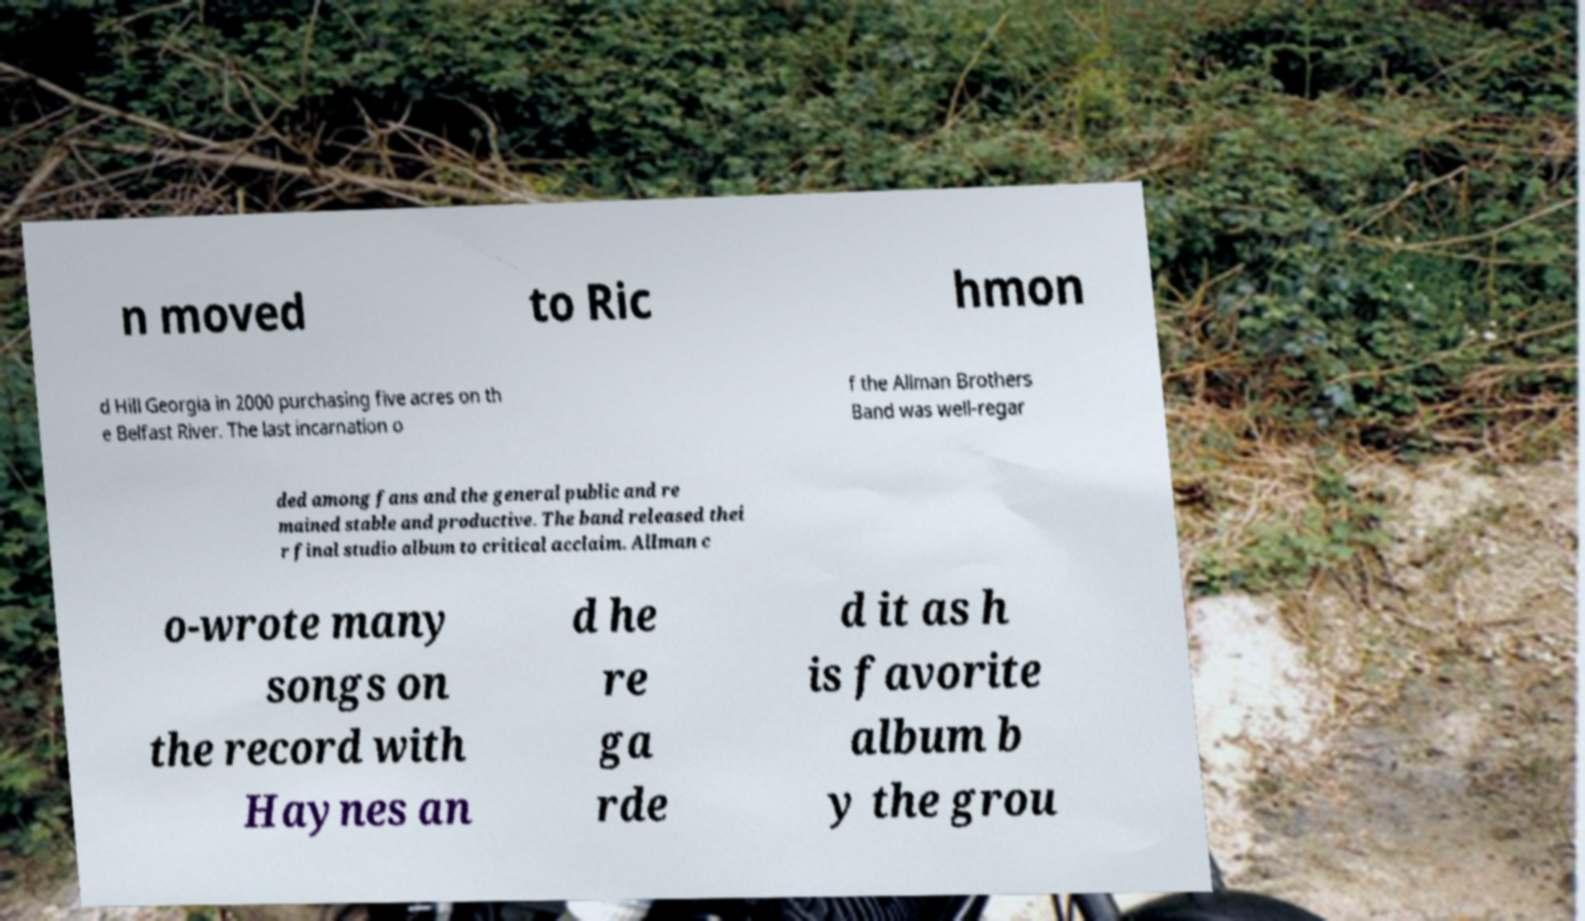Could you extract and type out the text from this image? n moved to Ric hmon d Hill Georgia in 2000 purchasing five acres on th e Belfast River. The last incarnation o f the Allman Brothers Band was well-regar ded among fans and the general public and re mained stable and productive. The band released thei r final studio album to critical acclaim. Allman c o-wrote many songs on the record with Haynes an d he re ga rde d it as h is favorite album b y the grou 